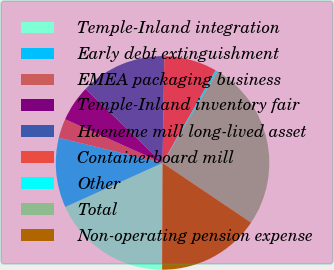Convert chart to OTSL. <chart><loc_0><loc_0><loc_500><loc_500><pie_chart><fcel>Temple-Inland integration<fcel>Early debt extinguishment<fcel>EMEA packaging business<fcel>Temple-Inland inventory fair<fcel>Hueneme mill long-lived asset<fcel>Containerboard mill<fcel>Other<fcel>Total<fcel>Non-operating pension expense<nl><fcel>18.17%<fcel>10.55%<fcel>2.93%<fcel>5.47%<fcel>13.09%<fcel>8.01%<fcel>0.38%<fcel>25.79%<fcel>15.63%<nl></chart> 